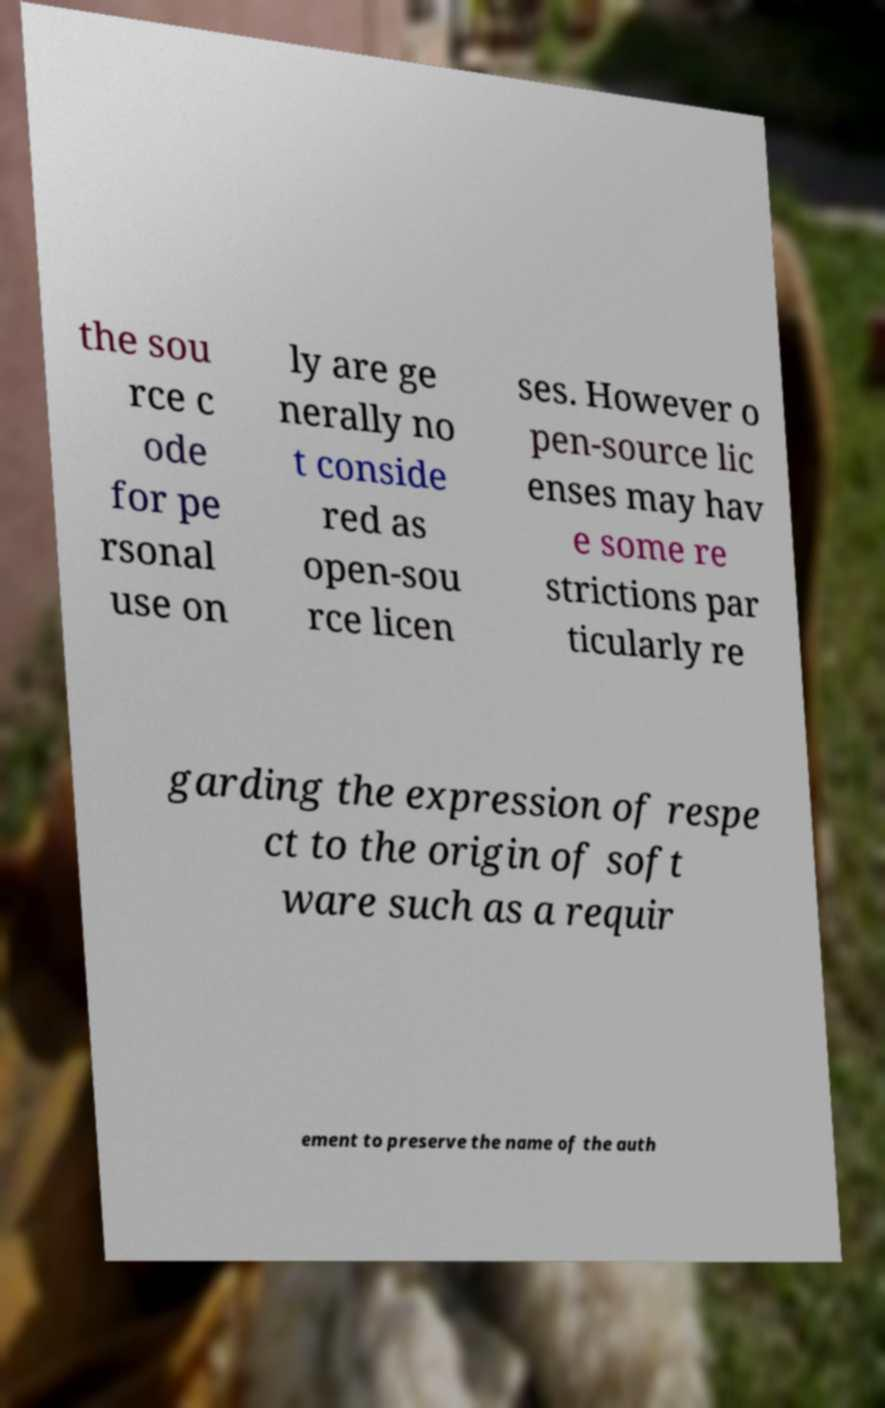Can you read and provide the text displayed in the image?This photo seems to have some interesting text. Can you extract and type it out for me? the sou rce c ode for pe rsonal use on ly are ge nerally no t conside red as open-sou rce licen ses. However o pen-source lic enses may hav e some re strictions par ticularly re garding the expression of respe ct to the origin of soft ware such as a requir ement to preserve the name of the auth 